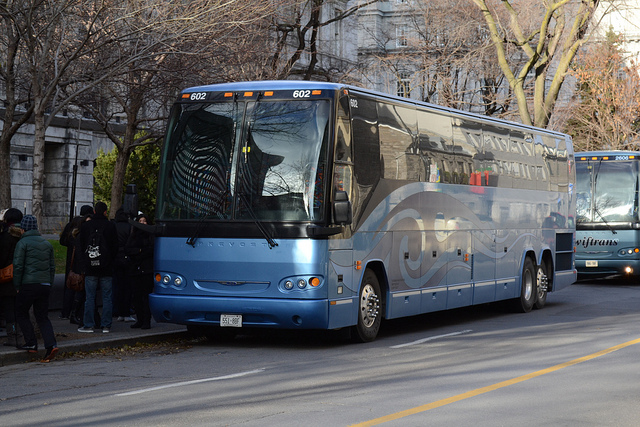How many tires are there? From the visible angle, there are at least four tires on the bus – two at the front and two at the back on one side. However, since buses are typically symmetrical vehicles, it is reasonable to infer that there are four more on the other side, making a total of eight tires usually found on such a coach-style bus. 